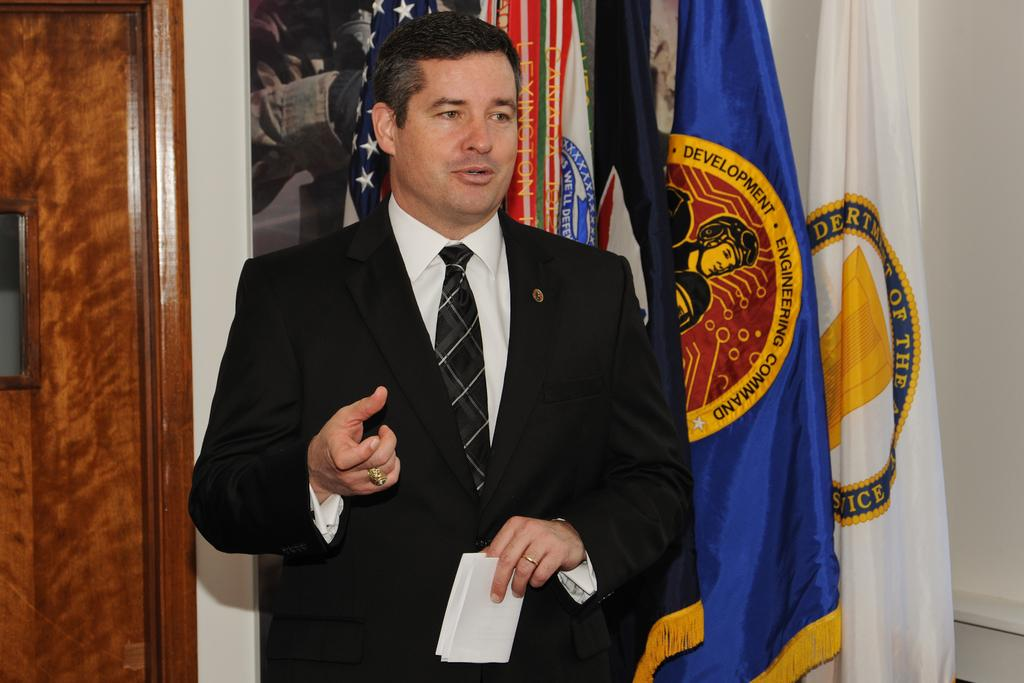<image>
Present a compact description of the photo's key features. a man is next to a flag that says development on it 